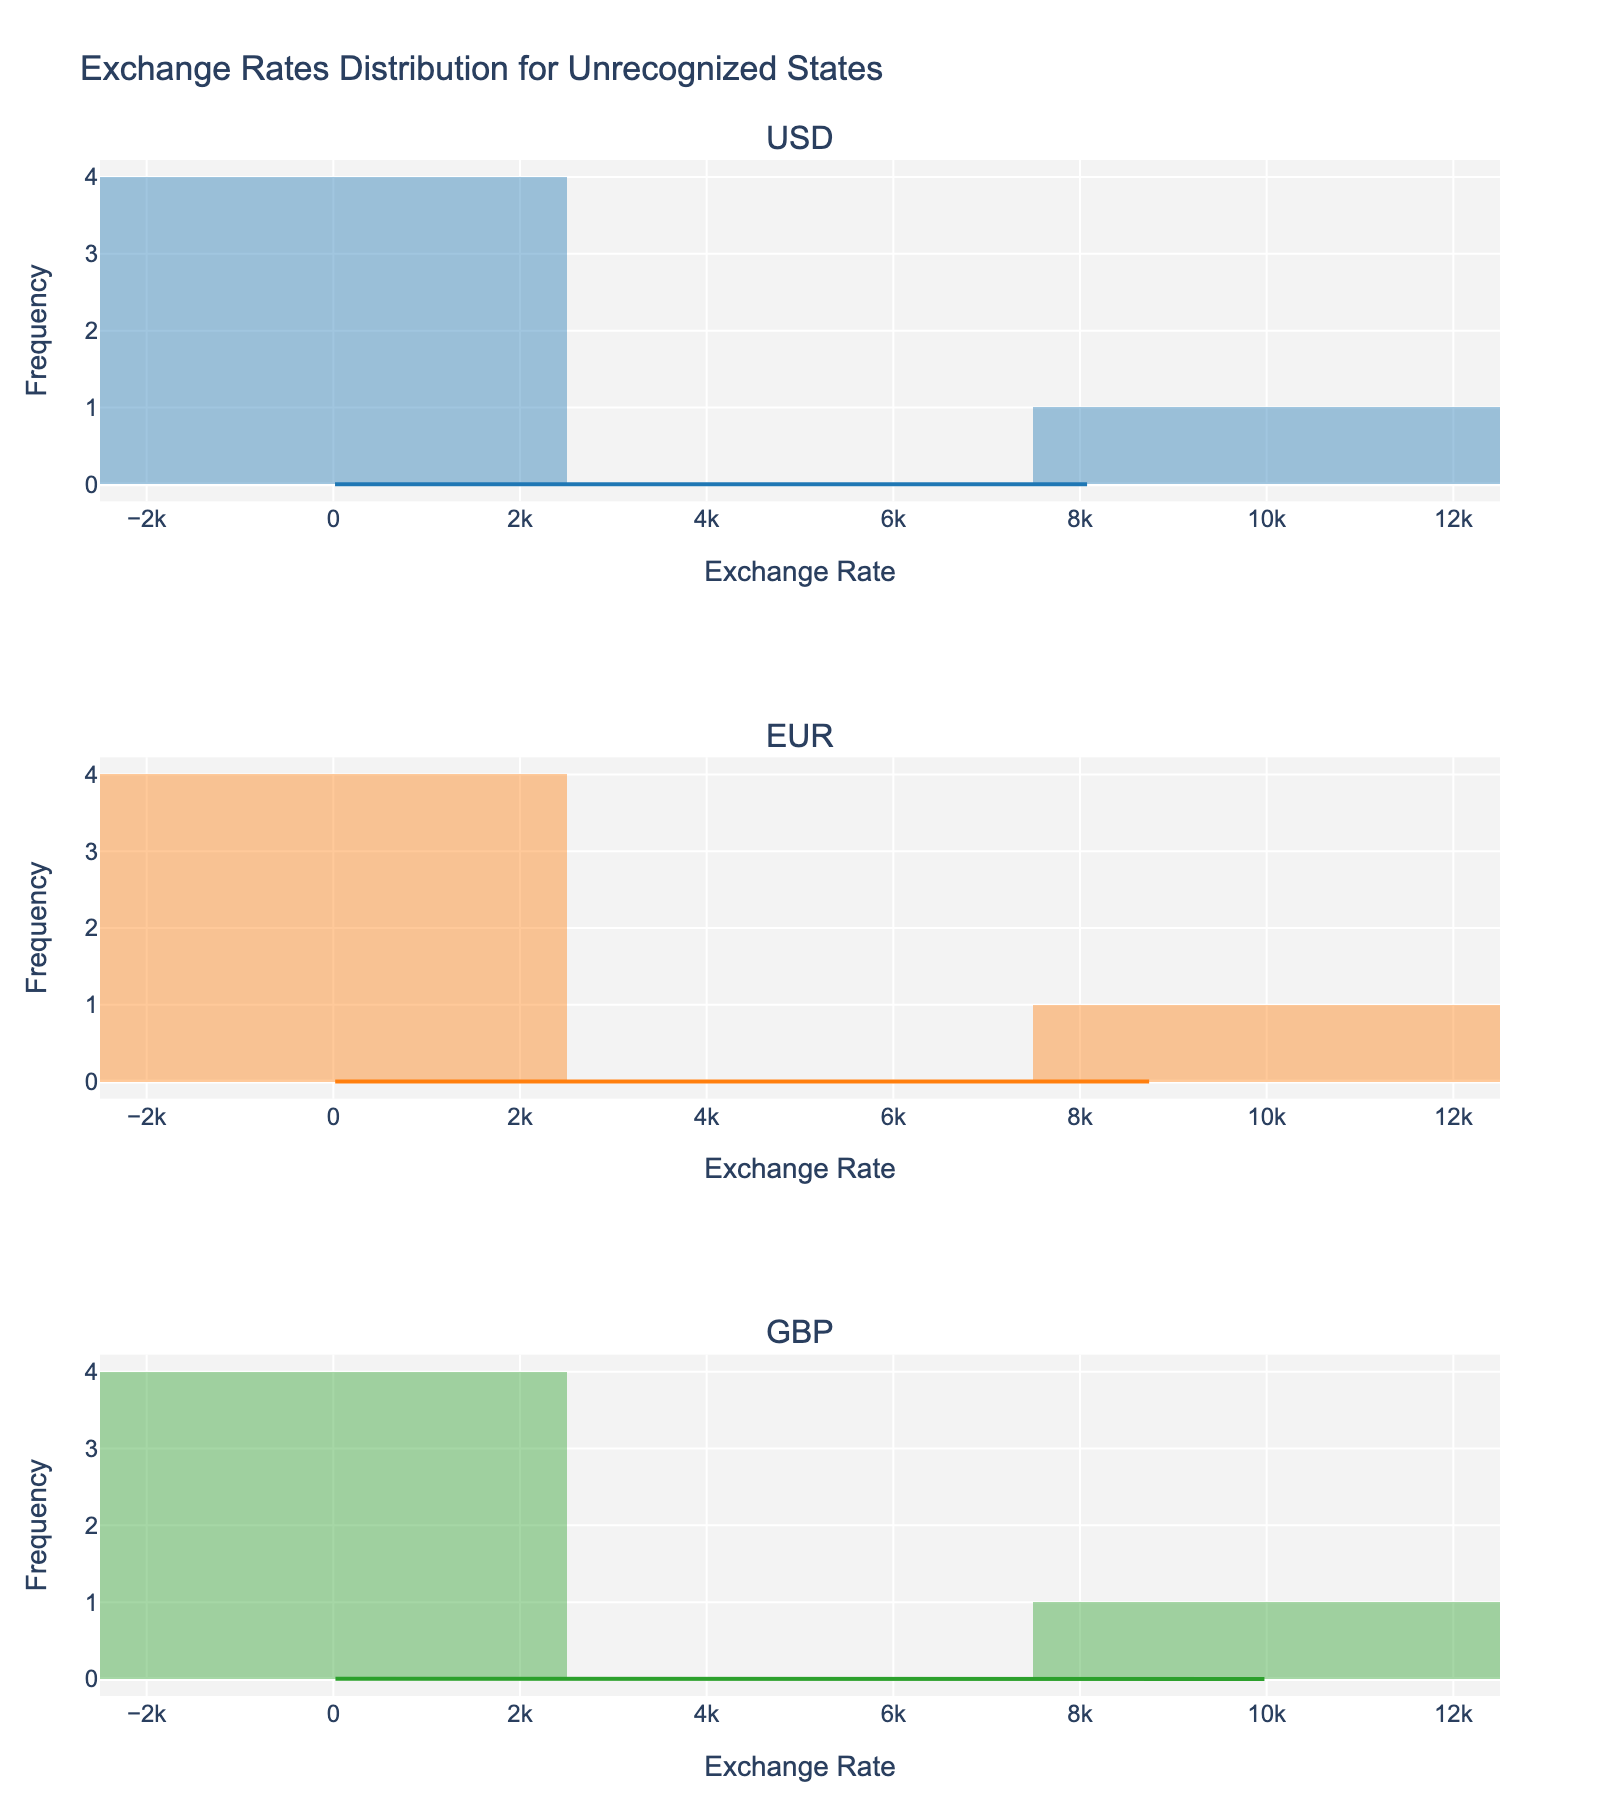What is the title of the figure? The title is usually positioned at the top of the figure. In this figure, it is clearly stated.
Answer: Exchange Rates Distribution for Unrecognized States Which exchange rate category (USD, EUR, GBP) has the highest peak in its histogram? To identify the highest peak, look at the histograms and determine which has the tallest bar.
Answer: USD How many subplots are there in the figure? The subplots are divided visibly by the horizontal gridlines. Count the number of distinct sections.
Answer: 3 Which exchange rate category has the widest range of values? Check the x-axes of each histogram and see which range spans the most value from the lowest to the highest.
Answer: USD Which currency pair in the USD category has the highest exchange rate? Look for the rightmost bar in the USD histogram and identify the corresponding label.
Answer: USD to Somaliland Shilling Is the USD exchange rate distribution skewed to the left or right? Observe the shape of the histogram and KDE. If most data is on the left with a tail stretching to the right, it's right-skewed.
Answer: Right-skewed Which category has the highest frequency density according to the KDE curve? Look at the KDE curves and see which one reaches the highest point on the y-axis.
Answer: USD What is the approximate exchange rate value where the EUR histogram has its highest bar? Check for the tallest bar in the EUR subplot and read the x-axis value directly below it.
Answer: Around 19.80-81.20 Compare the GBP and EUR exchange rate distributions: which has more spread out exchange rates? Compare the span of both x-axes by observing where the ranges start and end for each subplot and noting how spread out the values are.
Answer: GBP What is the median value of the USD exchange rates? Order the USD exchange rates and find the middle value. (18.25, 75.50, 82.75, 480.00, 8500.00) The sorted values are 18.25, 75.50, 82.75, 480.00, 8500.00. The median is 82.75.
Answer: 82.75 